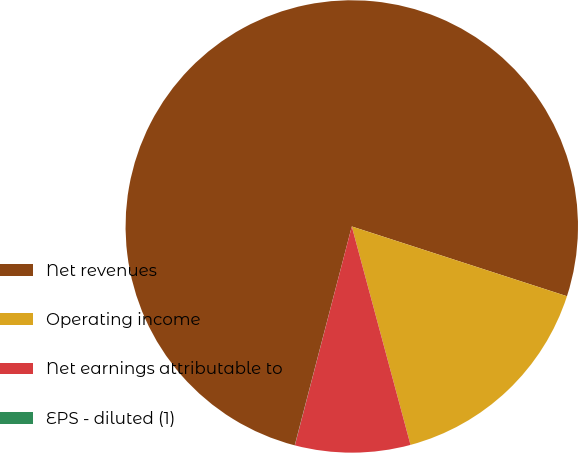<chart> <loc_0><loc_0><loc_500><loc_500><pie_chart><fcel>Net revenues<fcel>Operating income<fcel>Net earnings attributable to<fcel>EPS - diluted (1)<nl><fcel>75.93%<fcel>15.83%<fcel>8.23%<fcel>0.01%<nl></chart> 